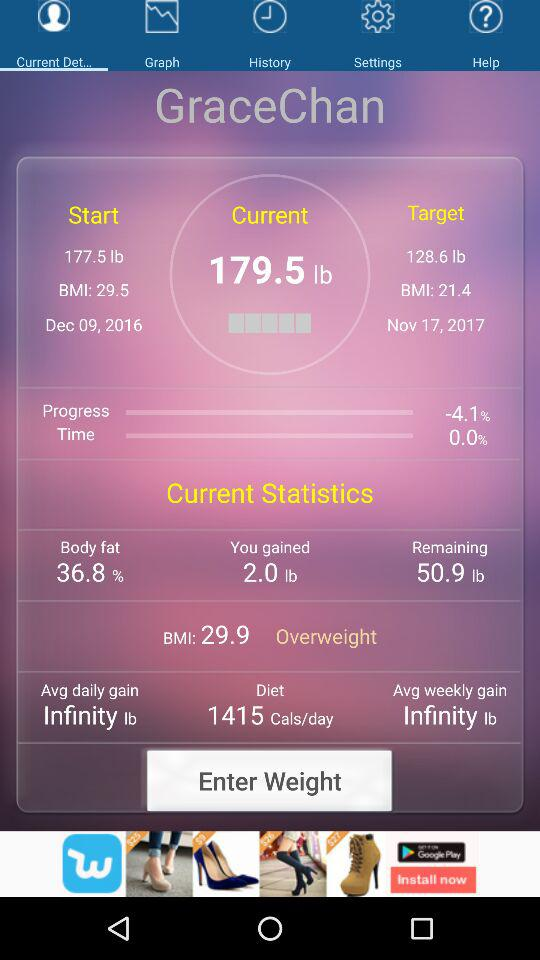What is the target weight? The target weight is 128.6 lb. 